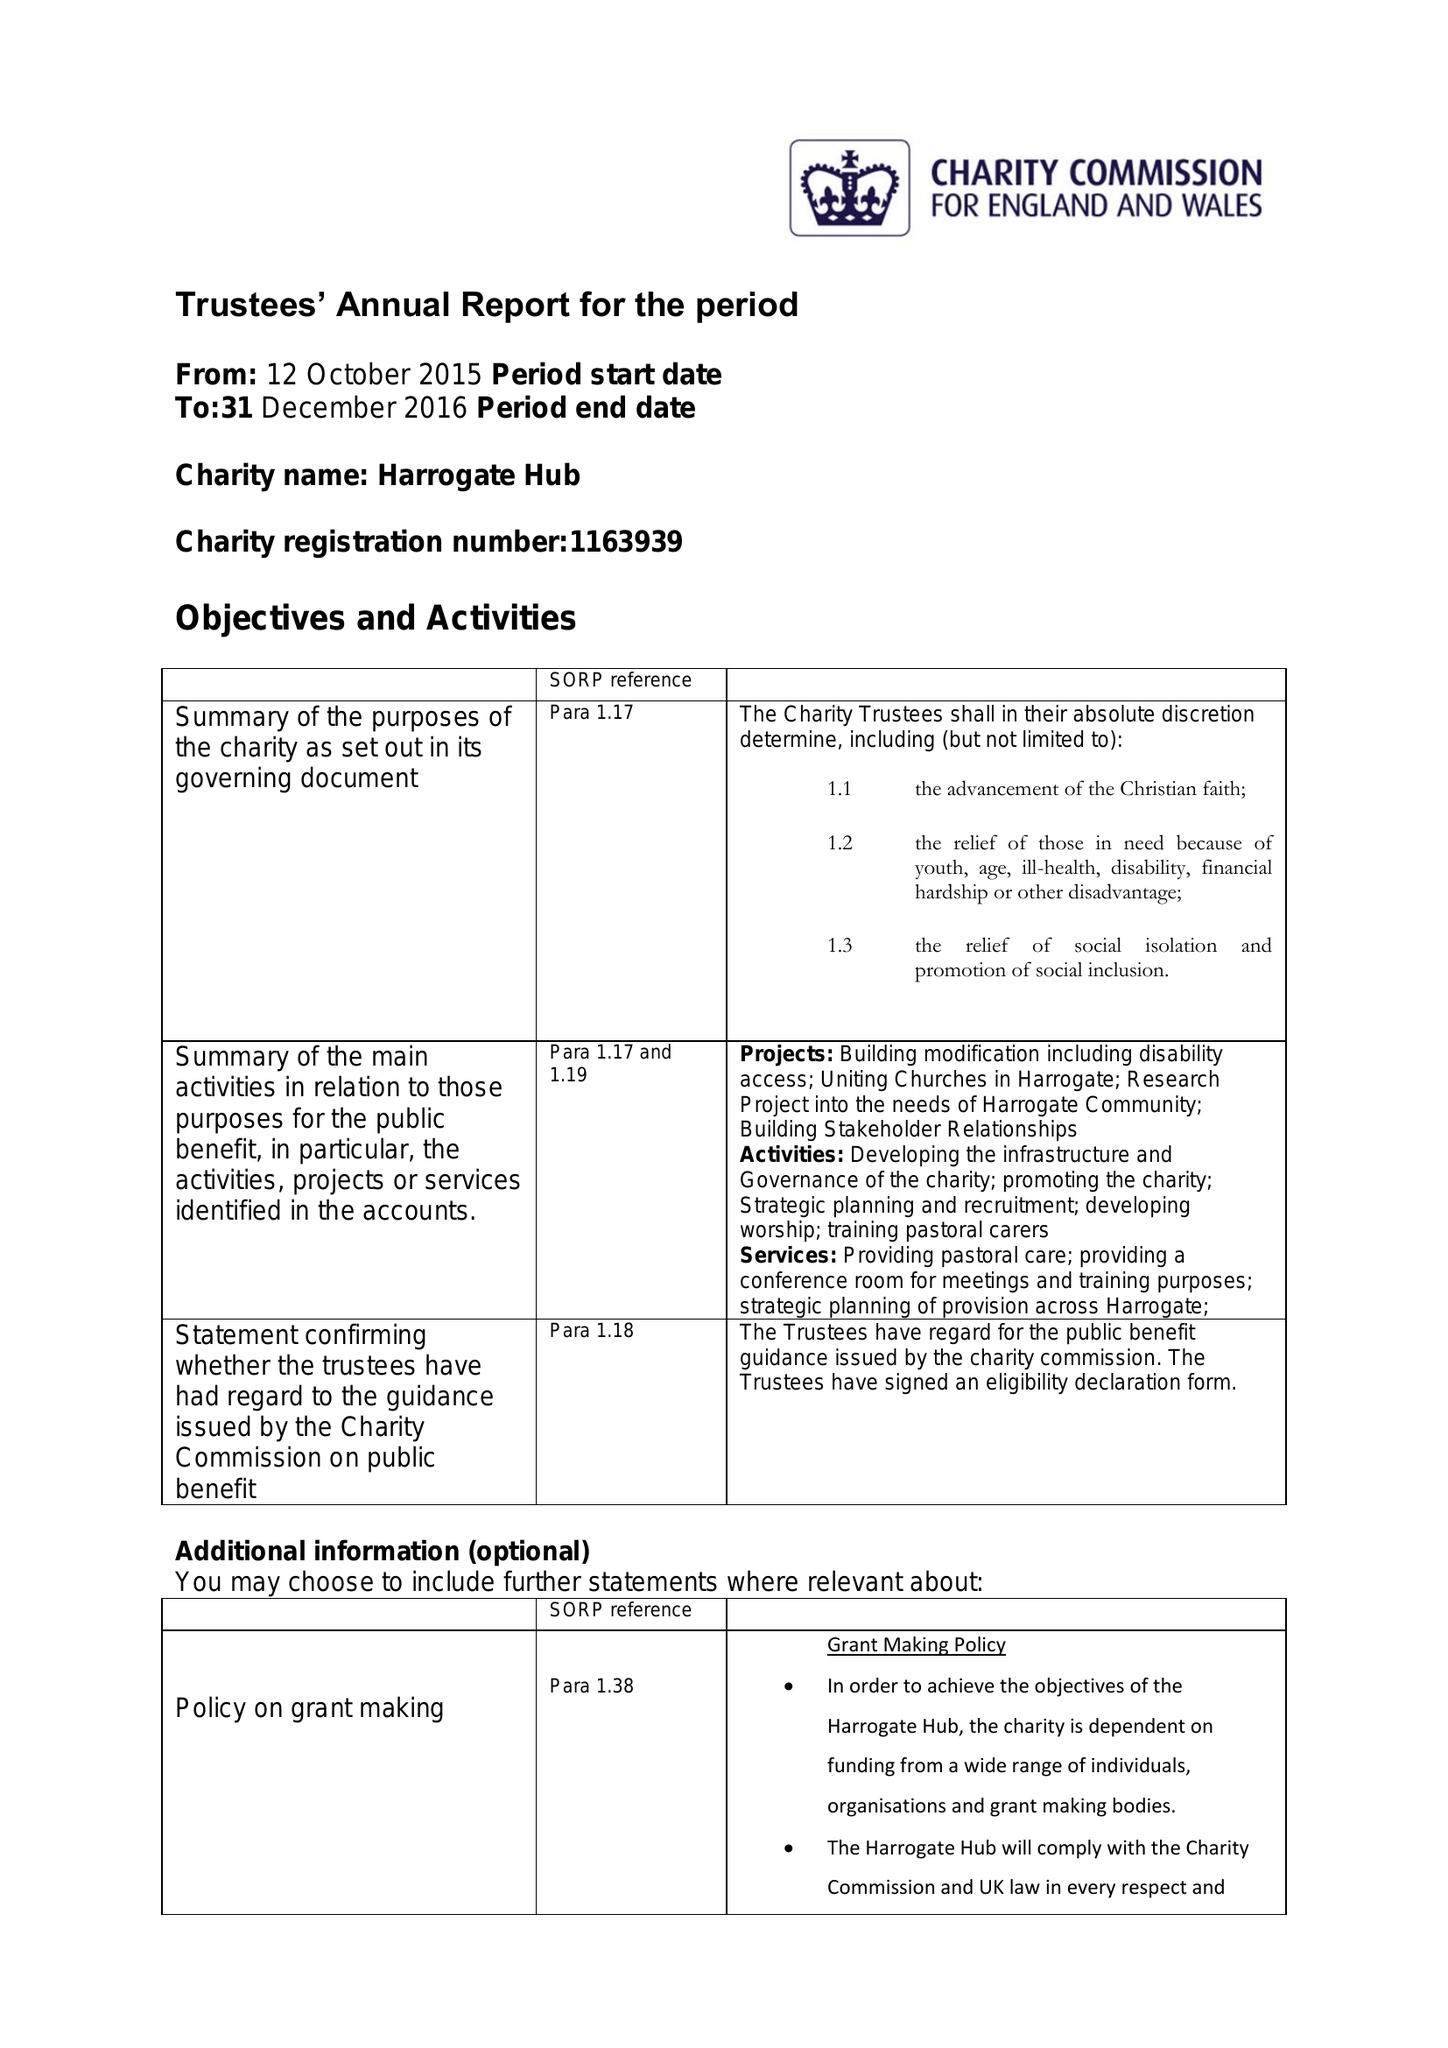What is the value for the report_date?
Answer the question using a single word or phrase. 2016-12-31 